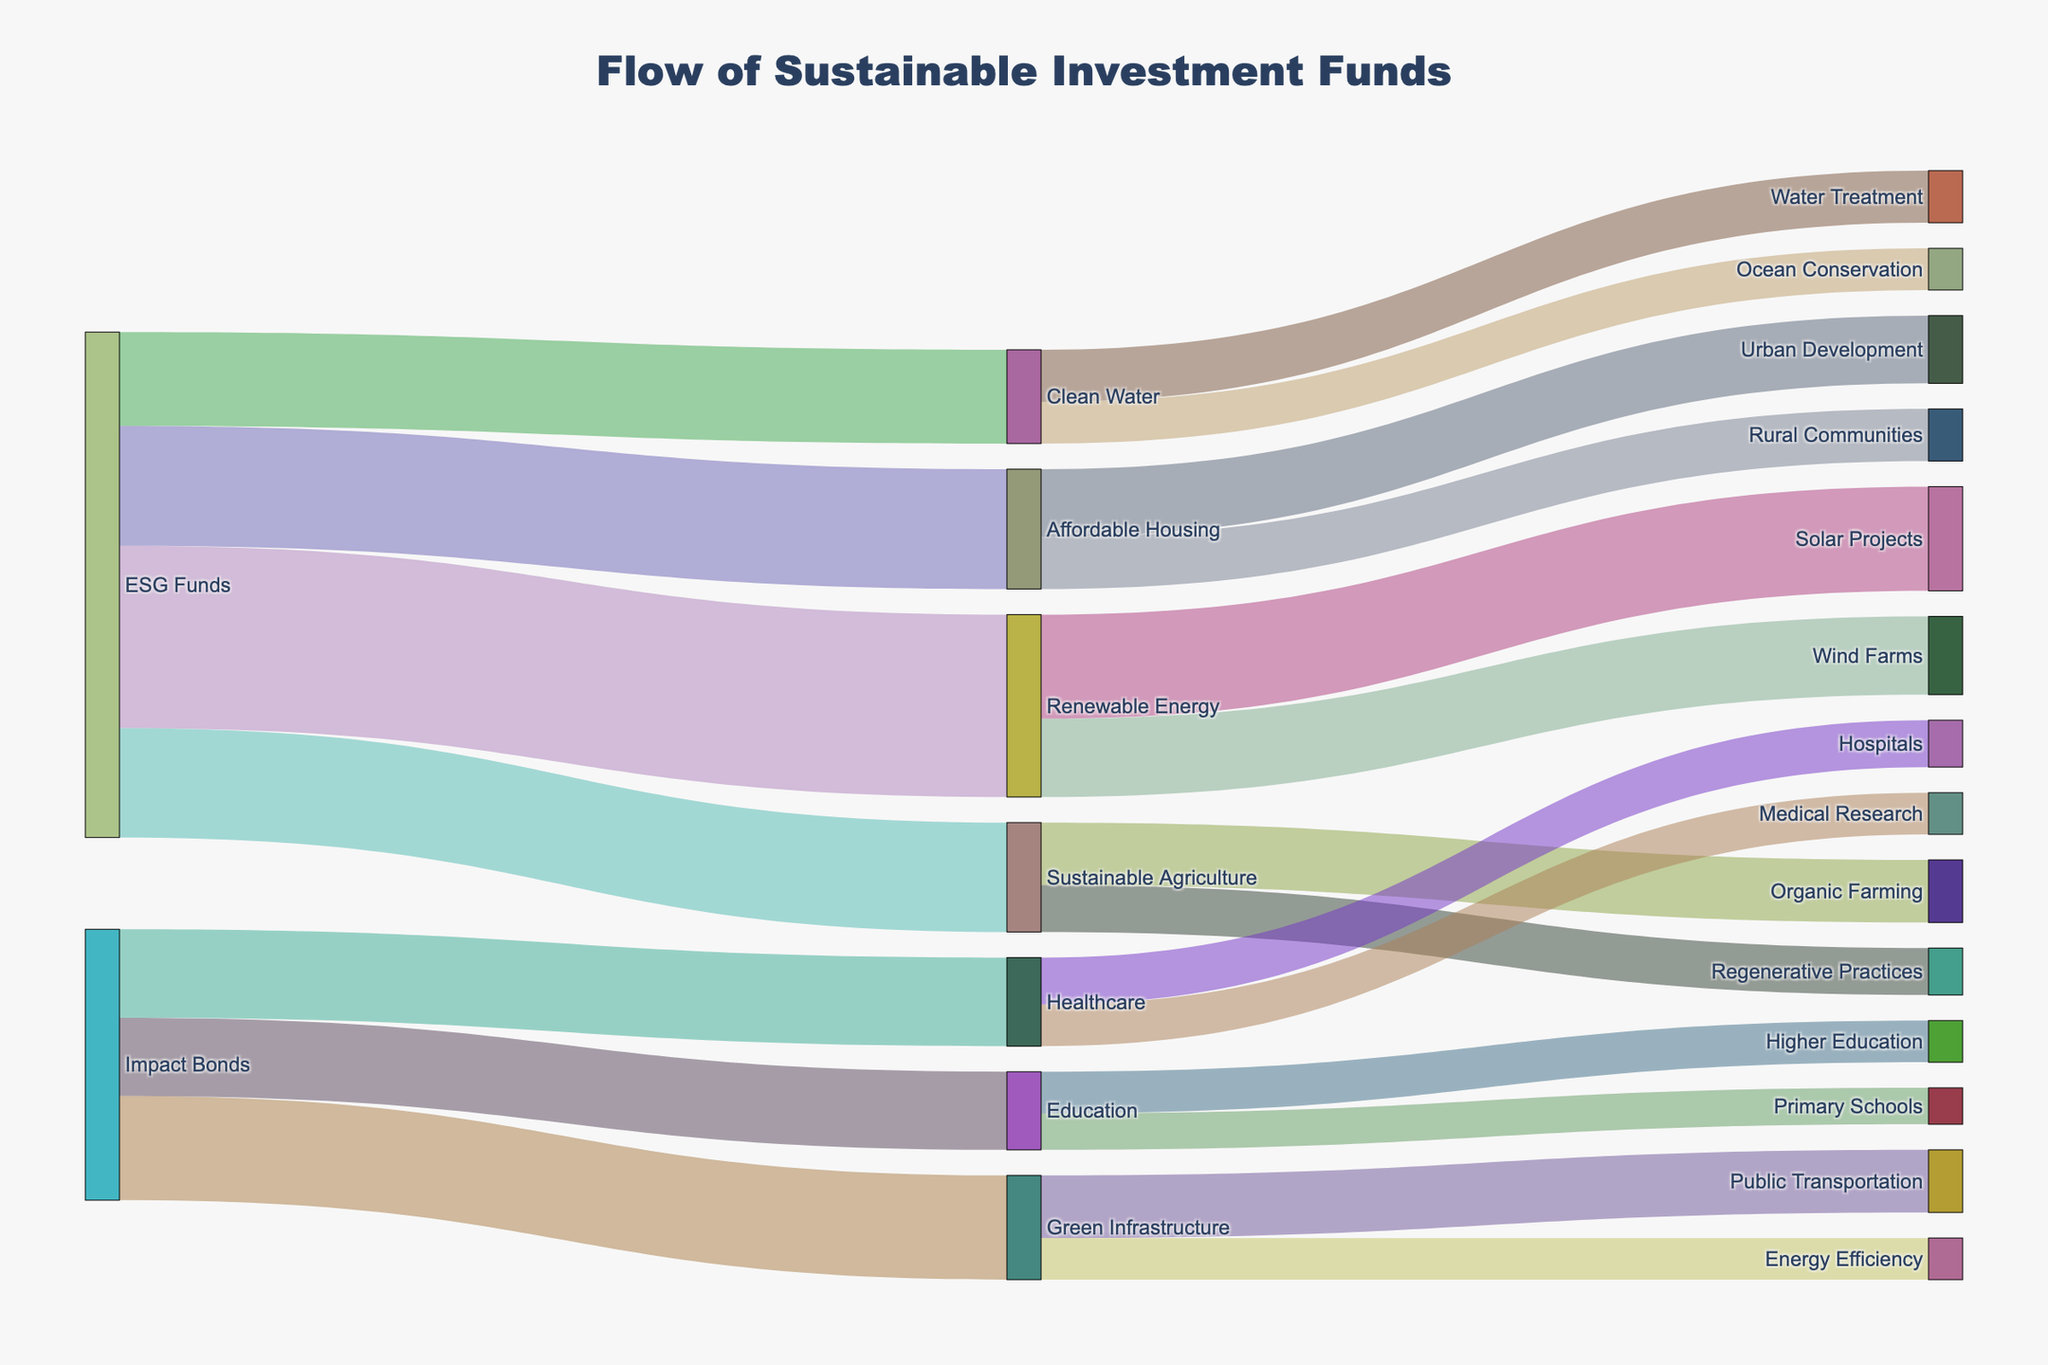What is the title of the Sankey diagram? The title of the diagram is usually placed at the top of the figure and gives a brief description of what the diagram represents.
Answer: Flow of Sustainable Investment Funds Which sector receives the highest investment from ESG Funds? Review the links coming from "ESG Funds" and check where the highest value flows. The link to "Renewable Energy" has the highest value.
Answer: Renewable Energy How much investment flows into Organic Farming from Sustainable Agriculture? Locate the flow between "Sustainable Agriculture" and "Organic Farming" and read the value associated with it.
Answer: 1200 What is the combined investment flowing into both Solar Projects and Wind Farms from Renewable Energy? Identify the individual investments flowing into "Solar Projects" and "Wind Farms" from "Renewable Energy." Sum these values: 2000 + 1500.
Answer: 3500 Which impact area receives investment from both Impact Bonds and ESG Funds, and what is the total? Check for impact areas that have incoming links from both "Impact Bonds" and "ESG Funds." Only "Green Infrastructure" fits this and sum the incoming values: 2000 (from Impact Bonds) + 0 (none from ESG Funds) = 2000.
Answer: Green Infrastructure, 2000 Which impact area related to Healthcare receives more investment, Hospitals or Medical Research? Find the flows into "Hospitals" and "Medical Research" from "Healthcare." Compare the values 900 (Hospitals) and 800 (Medical Research).
Answer: Hospitals What is the total investment in Clean Water projects (combine Water Treatment and Ocean Conservation)? Sum the values flowing into "Water Treatment" and "Ocean Conservation" from "Clean Water." The values are 1000 (Water Treatment) + 800 (Ocean Conservation).
Answer: 1800 Which sector has a balanced distribution of investments, comparing Renewable Energy and Affordable Housing? Compare how evenly the values flow into individual projects within "Renewable Energy" (2000 and 1500) and "Affordable Housing" (1300 and 1000). "Affordable Housing" shows a more balanced distribution as the values are closer to each other.
Answer: Affordable Housing Which has a greater total investment flow, Renewable Energy projects or Sustainable Agriculture projects? Sum the investments flowing into Renewable Energy projects (Solar Projects and Wind Farms) and Sustainable Agriculture projects (Organic Farming and Regenerative Practices) and compare. Renewable Energy: 2000 + 1500 = 3500, Sustainable Agriculture: 1200 + 900 = 2100.
Answer: Renewable Energy What is the largest single investment shown in the diagram? Identify the highest value among all the individual flows shown in the diagram. The highest value is the 3500 flowing from "ESG Funds" to "Renewable Energy."
Answer: 3500 